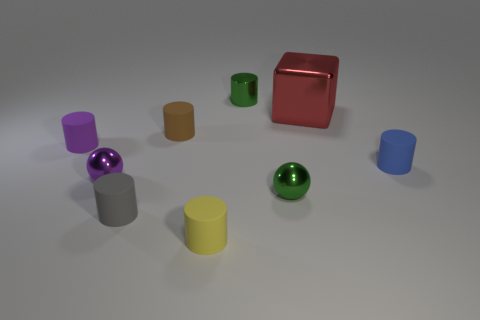What color is the metallic cylinder that is the same size as the yellow matte object?
Give a very brief answer. Green. How many other things are the same shape as the brown thing?
Ensure brevity in your answer.  5. Is there another green thing that has the same material as the large thing?
Provide a succinct answer. Yes. Is the small purple thing right of the tiny purple rubber object made of the same material as the tiny green object in front of the large thing?
Offer a very short reply. Yes. What number of yellow shiny balls are there?
Give a very brief answer. 0. What is the shape of the object that is behind the red thing?
Provide a succinct answer. Cylinder. What number of other things are there of the same size as the brown matte cylinder?
Your response must be concise. 7. Do the green thing behind the big red shiny block and the small rubber thing to the right of the shiny cube have the same shape?
Give a very brief answer. Yes. What number of brown cylinders are to the left of the brown rubber object?
Provide a succinct answer. 0. What color is the shiny ball to the right of the small brown rubber object?
Ensure brevity in your answer.  Green. 